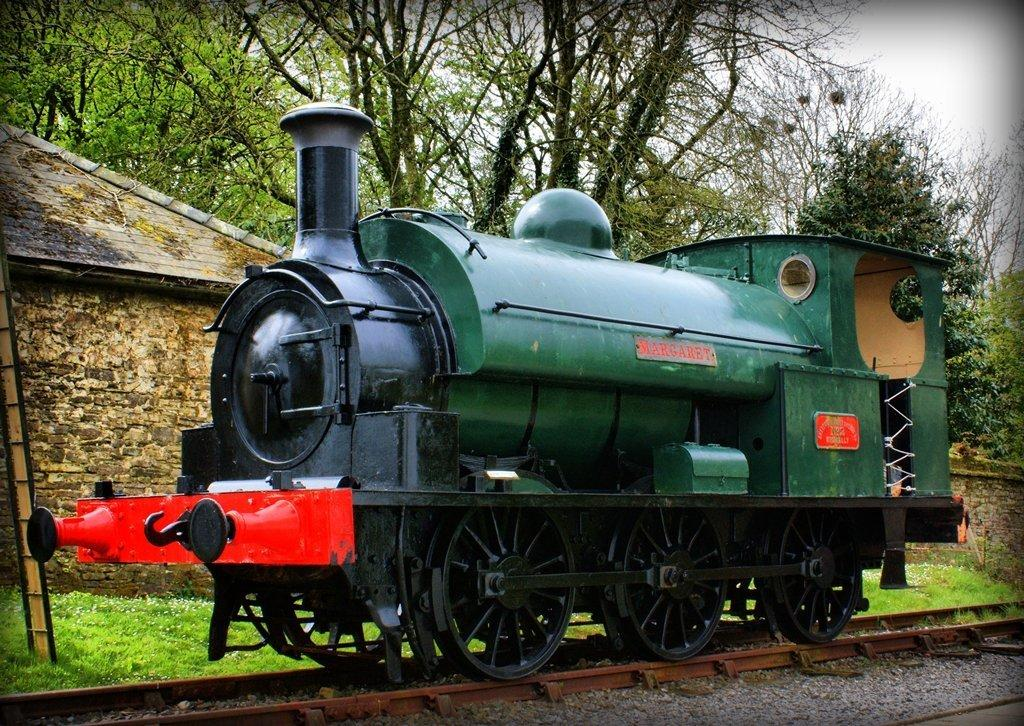What can be seen in the background of the image? In the background of the image, there is a sky, trees, a rooftop, grass, and a wall. What is located on the left side of the image? There is a ladder on the left side of the image. What is present on the track in the image? There is an engine on the track in the image. What type of drink is being served in the image? There is no drink present in the image. How many eyes can be seen on the quince in the image? There is no quince present in the image, and therefore no eyes to count. 